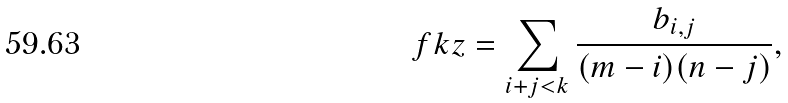<formula> <loc_0><loc_0><loc_500><loc_500>\ f k z = \sum _ { i + j < k } \frac { b _ { i , j } } { ( m - i ) ( n - j ) } ,</formula> 